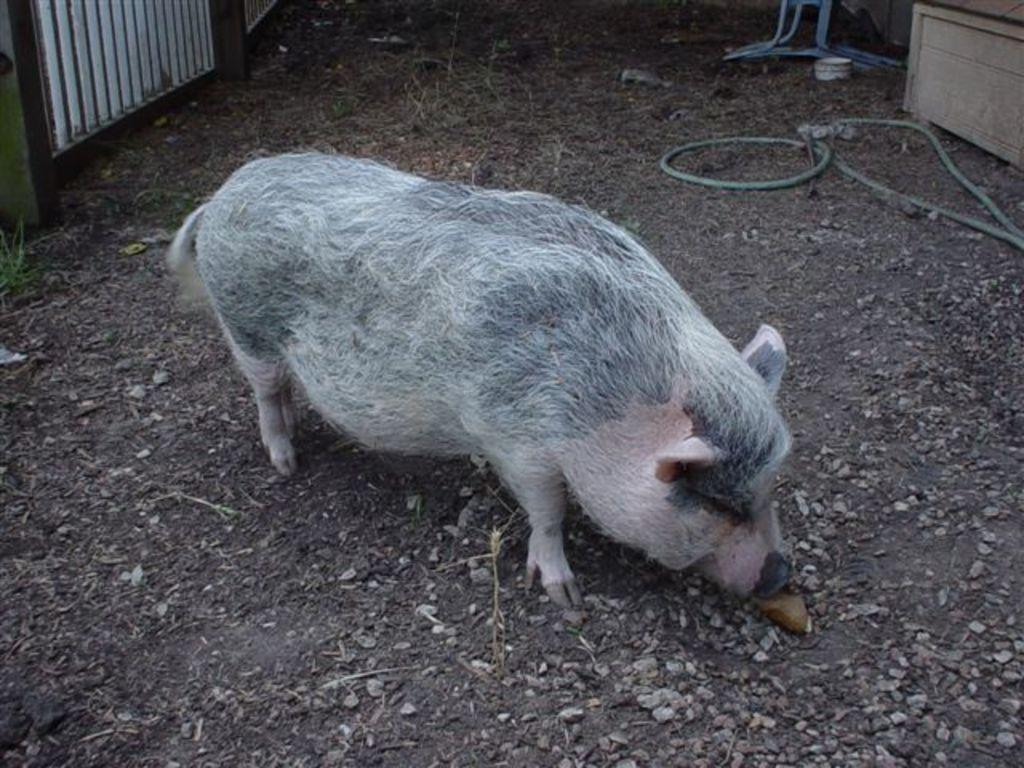What animal is standing in the image? There is a pig standing in the image. What can be seen at the bottom of the image? There are stones at the bottom of the image. Where is the pipe located in the image? The pipe is on the right side of the image. What type of birds can be seen flying in the image? There are no birds visible in the image. What advice might the pig's aunt give in the image? There is no mention of an aunt or any advice in the image. 